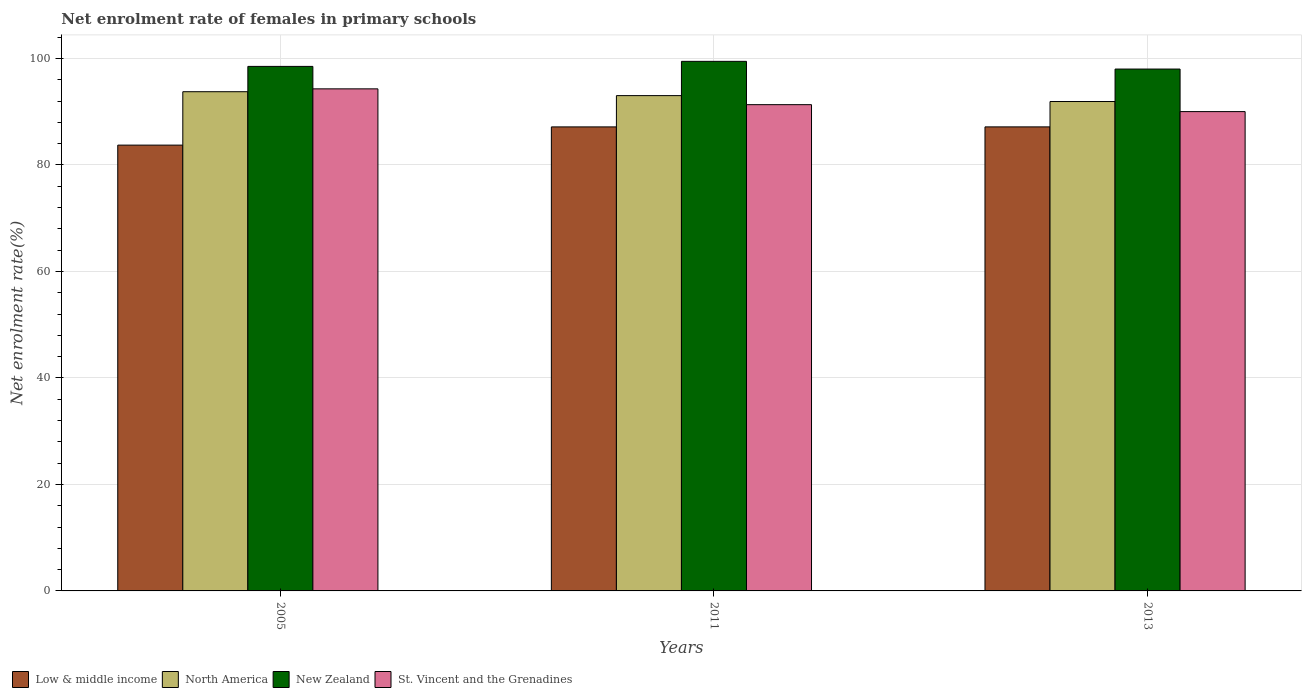Are the number of bars per tick equal to the number of legend labels?
Make the answer very short. Yes. Are the number of bars on each tick of the X-axis equal?
Provide a succinct answer. Yes. How many bars are there on the 1st tick from the left?
Provide a short and direct response. 4. How many bars are there on the 1st tick from the right?
Offer a terse response. 4. In how many cases, is the number of bars for a given year not equal to the number of legend labels?
Provide a succinct answer. 0. What is the net enrolment rate of females in primary schools in Low & middle income in 2005?
Ensure brevity in your answer.  83.73. Across all years, what is the maximum net enrolment rate of females in primary schools in North America?
Your response must be concise. 93.77. Across all years, what is the minimum net enrolment rate of females in primary schools in New Zealand?
Keep it short and to the point. 98.02. In which year was the net enrolment rate of females in primary schools in North America maximum?
Give a very brief answer. 2005. In which year was the net enrolment rate of females in primary schools in St. Vincent and the Grenadines minimum?
Your answer should be compact. 2013. What is the total net enrolment rate of females in primary schools in North America in the graph?
Offer a terse response. 278.72. What is the difference between the net enrolment rate of females in primary schools in Low & middle income in 2005 and that in 2011?
Make the answer very short. -3.42. What is the difference between the net enrolment rate of females in primary schools in New Zealand in 2011 and the net enrolment rate of females in primary schools in St. Vincent and the Grenadines in 2013?
Keep it short and to the point. 9.44. What is the average net enrolment rate of females in primary schools in North America per year?
Give a very brief answer. 92.91. In the year 2013, what is the difference between the net enrolment rate of females in primary schools in New Zealand and net enrolment rate of females in primary schools in Low & middle income?
Offer a very short reply. 10.86. What is the ratio of the net enrolment rate of females in primary schools in North America in 2005 to that in 2013?
Offer a terse response. 1.02. Is the net enrolment rate of females in primary schools in Low & middle income in 2005 less than that in 2011?
Ensure brevity in your answer.  Yes. What is the difference between the highest and the second highest net enrolment rate of females in primary schools in New Zealand?
Provide a succinct answer. 0.95. What is the difference between the highest and the lowest net enrolment rate of females in primary schools in New Zealand?
Offer a terse response. 1.45. In how many years, is the net enrolment rate of females in primary schools in St. Vincent and the Grenadines greater than the average net enrolment rate of females in primary schools in St. Vincent and the Grenadines taken over all years?
Offer a very short reply. 1. What does the 3rd bar from the left in 2013 represents?
Provide a short and direct response. New Zealand. What does the 1st bar from the right in 2005 represents?
Provide a short and direct response. St. Vincent and the Grenadines. Is it the case that in every year, the sum of the net enrolment rate of females in primary schools in North America and net enrolment rate of females in primary schools in New Zealand is greater than the net enrolment rate of females in primary schools in Low & middle income?
Provide a short and direct response. Yes. How many bars are there?
Offer a very short reply. 12. Does the graph contain grids?
Provide a short and direct response. Yes. How many legend labels are there?
Your answer should be very brief. 4. How are the legend labels stacked?
Keep it short and to the point. Horizontal. What is the title of the graph?
Your answer should be very brief. Net enrolment rate of females in primary schools. Does "Sri Lanka" appear as one of the legend labels in the graph?
Offer a terse response. No. What is the label or title of the Y-axis?
Ensure brevity in your answer.  Net enrolment rate(%). What is the Net enrolment rate(%) in Low & middle income in 2005?
Offer a very short reply. 83.73. What is the Net enrolment rate(%) in North America in 2005?
Keep it short and to the point. 93.77. What is the Net enrolment rate(%) in New Zealand in 2005?
Your answer should be very brief. 98.52. What is the Net enrolment rate(%) in St. Vincent and the Grenadines in 2005?
Provide a short and direct response. 94.3. What is the Net enrolment rate(%) of Low & middle income in 2011?
Give a very brief answer. 87.16. What is the Net enrolment rate(%) in North America in 2011?
Your answer should be compact. 93.03. What is the Net enrolment rate(%) of New Zealand in 2011?
Offer a very short reply. 99.47. What is the Net enrolment rate(%) of St. Vincent and the Grenadines in 2011?
Ensure brevity in your answer.  91.33. What is the Net enrolment rate(%) of Low & middle income in 2013?
Give a very brief answer. 87.16. What is the Net enrolment rate(%) of North America in 2013?
Offer a very short reply. 91.92. What is the Net enrolment rate(%) in New Zealand in 2013?
Keep it short and to the point. 98.02. What is the Net enrolment rate(%) in St. Vincent and the Grenadines in 2013?
Your response must be concise. 90.03. Across all years, what is the maximum Net enrolment rate(%) in Low & middle income?
Your answer should be compact. 87.16. Across all years, what is the maximum Net enrolment rate(%) of North America?
Offer a very short reply. 93.77. Across all years, what is the maximum Net enrolment rate(%) of New Zealand?
Keep it short and to the point. 99.47. Across all years, what is the maximum Net enrolment rate(%) in St. Vincent and the Grenadines?
Make the answer very short. 94.3. Across all years, what is the minimum Net enrolment rate(%) of Low & middle income?
Ensure brevity in your answer.  83.73. Across all years, what is the minimum Net enrolment rate(%) in North America?
Your response must be concise. 91.92. Across all years, what is the minimum Net enrolment rate(%) of New Zealand?
Your answer should be compact. 98.02. Across all years, what is the minimum Net enrolment rate(%) in St. Vincent and the Grenadines?
Make the answer very short. 90.03. What is the total Net enrolment rate(%) of Low & middle income in the graph?
Offer a very short reply. 258.05. What is the total Net enrolment rate(%) of North America in the graph?
Provide a short and direct response. 278.72. What is the total Net enrolment rate(%) of New Zealand in the graph?
Provide a short and direct response. 296.01. What is the total Net enrolment rate(%) of St. Vincent and the Grenadines in the graph?
Your response must be concise. 275.66. What is the difference between the Net enrolment rate(%) in Low & middle income in 2005 and that in 2011?
Your answer should be very brief. -3.42. What is the difference between the Net enrolment rate(%) in North America in 2005 and that in 2011?
Offer a very short reply. 0.74. What is the difference between the Net enrolment rate(%) of New Zealand in 2005 and that in 2011?
Your answer should be compact. -0.95. What is the difference between the Net enrolment rate(%) of St. Vincent and the Grenadines in 2005 and that in 2011?
Keep it short and to the point. 2.97. What is the difference between the Net enrolment rate(%) in Low & middle income in 2005 and that in 2013?
Keep it short and to the point. -3.43. What is the difference between the Net enrolment rate(%) in North America in 2005 and that in 2013?
Offer a very short reply. 1.84. What is the difference between the Net enrolment rate(%) of New Zealand in 2005 and that in 2013?
Your response must be concise. 0.5. What is the difference between the Net enrolment rate(%) in St. Vincent and the Grenadines in 2005 and that in 2013?
Give a very brief answer. 4.27. What is the difference between the Net enrolment rate(%) in Low & middle income in 2011 and that in 2013?
Keep it short and to the point. -0. What is the difference between the Net enrolment rate(%) of North America in 2011 and that in 2013?
Your answer should be compact. 1.11. What is the difference between the Net enrolment rate(%) in New Zealand in 2011 and that in 2013?
Your response must be concise. 1.45. What is the difference between the Net enrolment rate(%) of St. Vincent and the Grenadines in 2011 and that in 2013?
Keep it short and to the point. 1.3. What is the difference between the Net enrolment rate(%) in Low & middle income in 2005 and the Net enrolment rate(%) in North America in 2011?
Provide a succinct answer. -9.3. What is the difference between the Net enrolment rate(%) of Low & middle income in 2005 and the Net enrolment rate(%) of New Zealand in 2011?
Offer a very short reply. -15.73. What is the difference between the Net enrolment rate(%) of Low & middle income in 2005 and the Net enrolment rate(%) of St. Vincent and the Grenadines in 2011?
Offer a terse response. -7.6. What is the difference between the Net enrolment rate(%) in North America in 2005 and the Net enrolment rate(%) in New Zealand in 2011?
Provide a short and direct response. -5.7. What is the difference between the Net enrolment rate(%) in North America in 2005 and the Net enrolment rate(%) in St. Vincent and the Grenadines in 2011?
Offer a terse response. 2.43. What is the difference between the Net enrolment rate(%) of New Zealand in 2005 and the Net enrolment rate(%) of St. Vincent and the Grenadines in 2011?
Provide a succinct answer. 7.19. What is the difference between the Net enrolment rate(%) in Low & middle income in 2005 and the Net enrolment rate(%) in North America in 2013?
Your answer should be very brief. -8.19. What is the difference between the Net enrolment rate(%) of Low & middle income in 2005 and the Net enrolment rate(%) of New Zealand in 2013?
Make the answer very short. -14.29. What is the difference between the Net enrolment rate(%) in Low & middle income in 2005 and the Net enrolment rate(%) in St. Vincent and the Grenadines in 2013?
Ensure brevity in your answer.  -6.3. What is the difference between the Net enrolment rate(%) in North America in 2005 and the Net enrolment rate(%) in New Zealand in 2013?
Your answer should be very brief. -4.26. What is the difference between the Net enrolment rate(%) of North America in 2005 and the Net enrolment rate(%) of St. Vincent and the Grenadines in 2013?
Offer a terse response. 3.74. What is the difference between the Net enrolment rate(%) in New Zealand in 2005 and the Net enrolment rate(%) in St. Vincent and the Grenadines in 2013?
Your response must be concise. 8.49. What is the difference between the Net enrolment rate(%) in Low & middle income in 2011 and the Net enrolment rate(%) in North America in 2013?
Keep it short and to the point. -4.77. What is the difference between the Net enrolment rate(%) in Low & middle income in 2011 and the Net enrolment rate(%) in New Zealand in 2013?
Ensure brevity in your answer.  -10.86. What is the difference between the Net enrolment rate(%) in Low & middle income in 2011 and the Net enrolment rate(%) in St. Vincent and the Grenadines in 2013?
Offer a very short reply. -2.87. What is the difference between the Net enrolment rate(%) of North America in 2011 and the Net enrolment rate(%) of New Zealand in 2013?
Provide a short and direct response. -4.99. What is the difference between the Net enrolment rate(%) in North America in 2011 and the Net enrolment rate(%) in St. Vincent and the Grenadines in 2013?
Your response must be concise. 3. What is the difference between the Net enrolment rate(%) in New Zealand in 2011 and the Net enrolment rate(%) in St. Vincent and the Grenadines in 2013?
Keep it short and to the point. 9.44. What is the average Net enrolment rate(%) of Low & middle income per year?
Make the answer very short. 86.02. What is the average Net enrolment rate(%) of North America per year?
Your answer should be very brief. 92.91. What is the average Net enrolment rate(%) in New Zealand per year?
Provide a succinct answer. 98.67. What is the average Net enrolment rate(%) in St. Vincent and the Grenadines per year?
Keep it short and to the point. 91.89. In the year 2005, what is the difference between the Net enrolment rate(%) in Low & middle income and Net enrolment rate(%) in North America?
Your answer should be very brief. -10.03. In the year 2005, what is the difference between the Net enrolment rate(%) in Low & middle income and Net enrolment rate(%) in New Zealand?
Offer a terse response. -14.79. In the year 2005, what is the difference between the Net enrolment rate(%) of Low & middle income and Net enrolment rate(%) of St. Vincent and the Grenadines?
Your answer should be very brief. -10.57. In the year 2005, what is the difference between the Net enrolment rate(%) in North America and Net enrolment rate(%) in New Zealand?
Your response must be concise. -4.75. In the year 2005, what is the difference between the Net enrolment rate(%) in North America and Net enrolment rate(%) in St. Vincent and the Grenadines?
Your response must be concise. -0.54. In the year 2005, what is the difference between the Net enrolment rate(%) in New Zealand and Net enrolment rate(%) in St. Vincent and the Grenadines?
Offer a very short reply. 4.22. In the year 2011, what is the difference between the Net enrolment rate(%) of Low & middle income and Net enrolment rate(%) of North America?
Offer a very short reply. -5.87. In the year 2011, what is the difference between the Net enrolment rate(%) of Low & middle income and Net enrolment rate(%) of New Zealand?
Your answer should be compact. -12.31. In the year 2011, what is the difference between the Net enrolment rate(%) in Low & middle income and Net enrolment rate(%) in St. Vincent and the Grenadines?
Give a very brief answer. -4.17. In the year 2011, what is the difference between the Net enrolment rate(%) in North America and Net enrolment rate(%) in New Zealand?
Your response must be concise. -6.44. In the year 2011, what is the difference between the Net enrolment rate(%) of North America and Net enrolment rate(%) of St. Vincent and the Grenadines?
Offer a very short reply. 1.7. In the year 2011, what is the difference between the Net enrolment rate(%) of New Zealand and Net enrolment rate(%) of St. Vincent and the Grenadines?
Ensure brevity in your answer.  8.14. In the year 2013, what is the difference between the Net enrolment rate(%) in Low & middle income and Net enrolment rate(%) in North America?
Keep it short and to the point. -4.76. In the year 2013, what is the difference between the Net enrolment rate(%) in Low & middle income and Net enrolment rate(%) in New Zealand?
Provide a succinct answer. -10.86. In the year 2013, what is the difference between the Net enrolment rate(%) in Low & middle income and Net enrolment rate(%) in St. Vincent and the Grenadines?
Give a very brief answer. -2.87. In the year 2013, what is the difference between the Net enrolment rate(%) of North America and Net enrolment rate(%) of New Zealand?
Offer a terse response. -6.1. In the year 2013, what is the difference between the Net enrolment rate(%) of North America and Net enrolment rate(%) of St. Vincent and the Grenadines?
Your answer should be very brief. 1.89. In the year 2013, what is the difference between the Net enrolment rate(%) in New Zealand and Net enrolment rate(%) in St. Vincent and the Grenadines?
Provide a short and direct response. 7.99. What is the ratio of the Net enrolment rate(%) in Low & middle income in 2005 to that in 2011?
Offer a terse response. 0.96. What is the ratio of the Net enrolment rate(%) of North America in 2005 to that in 2011?
Give a very brief answer. 1.01. What is the ratio of the Net enrolment rate(%) in New Zealand in 2005 to that in 2011?
Keep it short and to the point. 0.99. What is the ratio of the Net enrolment rate(%) in St. Vincent and the Grenadines in 2005 to that in 2011?
Provide a short and direct response. 1.03. What is the ratio of the Net enrolment rate(%) of Low & middle income in 2005 to that in 2013?
Your response must be concise. 0.96. What is the ratio of the Net enrolment rate(%) of New Zealand in 2005 to that in 2013?
Your response must be concise. 1.01. What is the ratio of the Net enrolment rate(%) in St. Vincent and the Grenadines in 2005 to that in 2013?
Offer a terse response. 1.05. What is the ratio of the Net enrolment rate(%) in Low & middle income in 2011 to that in 2013?
Provide a succinct answer. 1. What is the ratio of the Net enrolment rate(%) in North America in 2011 to that in 2013?
Ensure brevity in your answer.  1.01. What is the ratio of the Net enrolment rate(%) in New Zealand in 2011 to that in 2013?
Your answer should be very brief. 1.01. What is the ratio of the Net enrolment rate(%) in St. Vincent and the Grenadines in 2011 to that in 2013?
Offer a terse response. 1.01. What is the difference between the highest and the second highest Net enrolment rate(%) of Low & middle income?
Offer a very short reply. 0. What is the difference between the highest and the second highest Net enrolment rate(%) in North America?
Make the answer very short. 0.74. What is the difference between the highest and the second highest Net enrolment rate(%) of New Zealand?
Your response must be concise. 0.95. What is the difference between the highest and the second highest Net enrolment rate(%) of St. Vincent and the Grenadines?
Make the answer very short. 2.97. What is the difference between the highest and the lowest Net enrolment rate(%) in Low & middle income?
Your response must be concise. 3.43. What is the difference between the highest and the lowest Net enrolment rate(%) of North America?
Give a very brief answer. 1.84. What is the difference between the highest and the lowest Net enrolment rate(%) in New Zealand?
Keep it short and to the point. 1.45. What is the difference between the highest and the lowest Net enrolment rate(%) of St. Vincent and the Grenadines?
Keep it short and to the point. 4.27. 